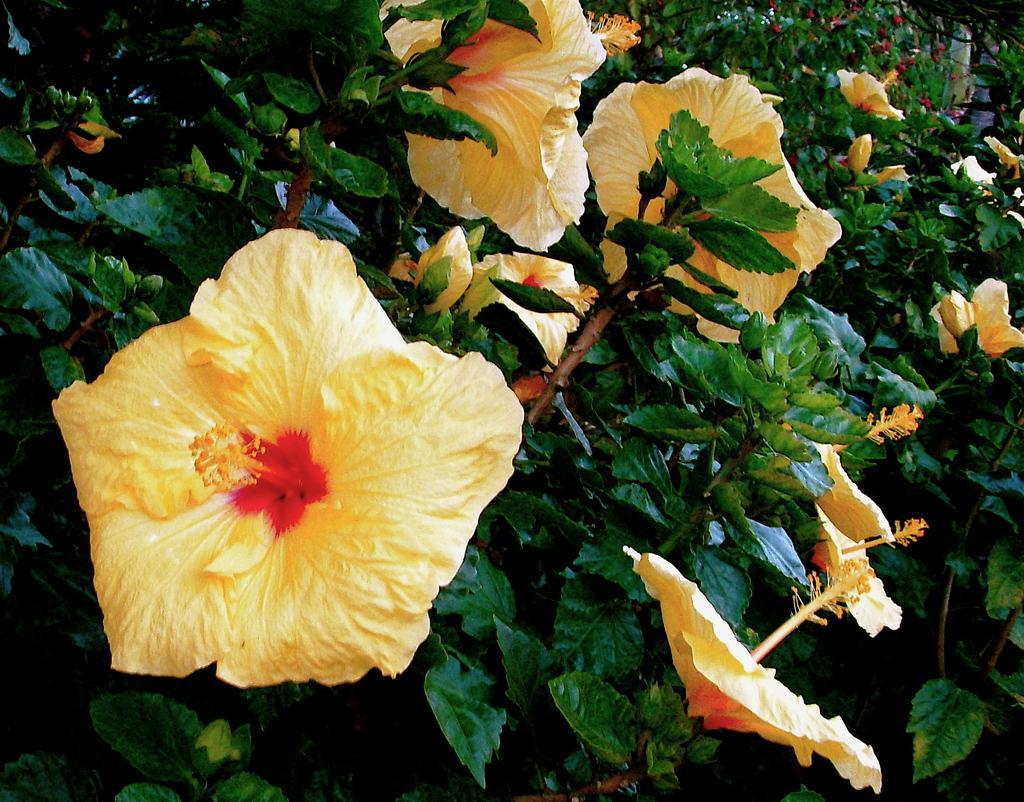Describe this image in one or two sentences. In the image I can see the flowering plants. 